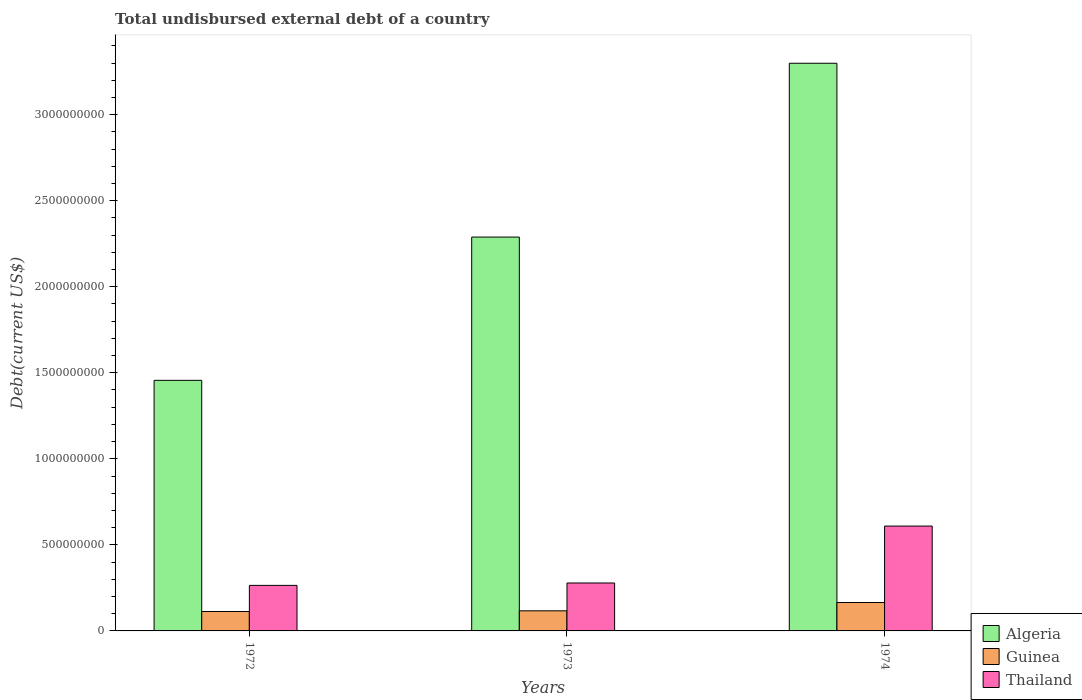How many different coloured bars are there?
Provide a short and direct response. 3. Are the number of bars per tick equal to the number of legend labels?
Your response must be concise. Yes. How many bars are there on the 1st tick from the left?
Offer a very short reply. 3. What is the label of the 3rd group of bars from the left?
Keep it short and to the point. 1974. In how many cases, is the number of bars for a given year not equal to the number of legend labels?
Offer a terse response. 0. What is the total undisbursed external debt in Guinea in 1972?
Your response must be concise. 1.13e+08. Across all years, what is the maximum total undisbursed external debt in Guinea?
Your answer should be very brief. 1.65e+08. Across all years, what is the minimum total undisbursed external debt in Guinea?
Your answer should be compact. 1.13e+08. In which year was the total undisbursed external debt in Thailand maximum?
Offer a terse response. 1974. In which year was the total undisbursed external debt in Algeria minimum?
Your answer should be compact. 1972. What is the total total undisbursed external debt in Thailand in the graph?
Offer a very short reply. 1.15e+09. What is the difference between the total undisbursed external debt in Algeria in 1973 and that in 1974?
Offer a terse response. -1.01e+09. What is the difference between the total undisbursed external debt in Guinea in 1974 and the total undisbursed external debt in Algeria in 1972?
Make the answer very short. -1.29e+09. What is the average total undisbursed external debt in Algeria per year?
Provide a succinct answer. 2.35e+09. In the year 1974, what is the difference between the total undisbursed external debt in Guinea and total undisbursed external debt in Algeria?
Provide a succinct answer. -3.13e+09. In how many years, is the total undisbursed external debt in Guinea greater than 1300000000 US$?
Ensure brevity in your answer.  0. What is the ratio of the total undisbursed external debt in Algeria in 1972 to that in 1974?
Make the answer very short. 0.44. Is the total undisbursed external debt in Thailand in 1973 less than that in 1974?
Give a very brief answer. Yes. Is the difference between the total undisbursed external debt in Guinea in 1972 and 1973 greater than the difference between the total undisbursed external debt in Algeria in 1972 and 1973?
Your answer should be very brief. Yes. What is the difference between the highest and the second highest total undisbursed external debt in Guinea?
Ensure brevity in your answer.  4.82e+07. What is the difference between the highest and the lowest total undisbursed external debt in Algeria?
Offer a very short reply. 1.84e+09. In how many years, is the total undisbursed external debt in Guinea greater than the average total undisbursed external debt in Guinea taken over all years?
Provide a succinct answer. 1. Is the sum of the total undisbursed external debt in Algeria in 1972 and 1974 greater than the maximum total undisbursed external debt in Thailand across all years?
Provide a short and direct response. Yes. What does the 1st bar from the left in 1973 represents?
Offer a terse response. Algeria. What does the 3rd bar from the right in 1972 represents?
Offer a very short reply. Algeria. How many years are there in the graph?
Offer a very short reply. 3. What is the difference between two consecutive major ticks on the Y-axis?
Provide a short and direct response. 5.00e+08. Are the values on the major ticks of Y-axis written in scientific E-notation?
Offer a terse response. No. Does the graph contain any zero values?
Ensure brevity in your answer.  No. Where does the legend appear in the graph?
Ensure brevity in your answer.  Bottom right. How many legend labels are there?
Make the answer very short. 3. What is the title of the graph?
Your answer should be very brief. Total undisbursed external debt of a country. Does "Least developed countries" appear as one of the legend labels in the graph?
Give a very brief answer. No. What is the label or title of the X-axis?
Provide a short and direct response. Years. What is the label or title of the Y-axis?
Your answer should be very brief. Debt(current US$). What is the Debt(current US$) in Algeria in 1972?
Your answer should be very brief. 1.46e+09. What is the Debt(current US$) in Guinea in 1972?
Your response must be concise. 1.13e+08. What is the Debt(current US$) in Thailand in 1972?
Ensure brevity in your answer.  2.65e+08. What is the Debt(current US$) of Algeria in 1973?
Provide a short and direct response. 2.29e+09. What is the Debt(current US$) in Guinea in 1973?
Give a very brief answer. 1.17e+08. What is the Debt(current US$) of Thailand in 1973?
Make the answer very short. 2.79e+08. What is the Debt(current US$) of Algeria in 1974?
Offer a very short reply. 3.30e+09. What is the Debt(current US$) of Guinea in 1974?
Your answer should be compact. 1.65e+08. What is the Debt(current US$) in Thailand in 1974?
Provide a short and direct response. 6.09e+08. Across all years, what is the maximum Debt(current US$) in Algeria?
Provide a succinct answer. 3.30e+09. Across all years, what is the maximum Debt(current US$) of Guinea?
Provide a short and direct response. 1.65e+08. Across all years, what is the maximum Debt(current US$) of Thailand?
Keep it short and to the point. 6.09e+08. Across all years, what is the minimum Debt(current US$) of Algeria?
Give a very brief answer. 1.46e+09. Across all years, what is the minimum Debt(current US$) of Guinea?
Give a very brief answer. 1.13e+08. Across all years, what is the minimum Debt(current US$) in Thailand?
Make the answer very short. 2.65e+08. What is the total Debt(current US$) of Algeria in the graph?
Keep it short and to the point. 7.04e+09. What is the total Debt(current US$) in Guinea in the graph?
Offer a terse response. 3.95e+08. What is the total Debt(current US$) in Thailand in the graph?
Provide a succinct answer. 1.15e+09. What is the difference between the Debt(current US$) of Algeria in 1972 and that in 1973?
Give a very brief answer. -8.32e+08. What is the difference between the Debt(current US$) in Guinea in 1972 and that in 1973?
Offer a very short reply. -3.91e+06. What is the difference between the Debt(current US$) of Thailand in 1972 and that in 1973?
Provide a succinct answer. -1.39e+07. What is the difference between the Debt(current US$) in Algeria in 1972 and that in 1974?
Provide a short and direct response. -1.84e+09. What is the difference between the Debt(current US$) in Guinea in 1972 and that in 1974?
Give a very brief answer. -5.21e+07. What is the difference between the Debt(current US$) of Thailand in 1972 and that in 1974?
Your answer should be compact. -3.45e+08. What is the difference between the Debt(current US$) of Algeria in 1973 and that in 1974?
Ensure brevity in your answer.  -1.01e+09. What is the difference between the Debt(current US$) in Guinea in 1973 and that in 1974?
Give a very brief answer. -4.82e+07. What is the difference between the Debt(current US$) in Thailand in 1973 and that in 1974?
Offer a very short reply. -3.31e+08. What is the difference between the Debt(current US$) in Algeria in 1972 and the Debt(current US$) in Guinea in 1973?
Provide a short and direct response. 1.34e+09. What is the difference between the Debt(current US$) in Algeria in 1972 and the Debt(current US$) in Thailand in 1973?
Offer a very short reply. 1.18e+09. What is the difference between the Debt(current US$) in Guinea in 1972 and the Debt(current US$) in Thailand in 1973?
Give a very brief answer. -1.66e+08. What is the difference between the Debt(current US$) in Algeria in 1972 and the Debt(current US$) in Guinea in 1974?
Keep it short and to the point. 1.29e+09. What is the difference between the Debt(current US$) in Algeria in 1972 and the Debt(current US$) in Thailand in 1974?
Offer a very short reply. 8.47e+08. What is the difference between the Debt(current US$) of Guinea in 1972 and the Debt(current US$) of Thailand in 1974?
Provide a short and direct response. -4.96e+08. What is the difference between the Debt(current US$) in Algeria in 1973 and the Debt(current US$) in Guinea in 1974?
Make the answer very short. 2.12e+09. What is the difference between the Debt(current US$) in Algeria in 1973 and the Debt(current US$) in Thailand in 1974?
Provide a short and direct response. 1.68e+09. What is the difference between the Debt(current US$) of Guinea in 1973 and the Debt(current US$) of Thailand in 1974?
Provide a succinct answer. -4.92e+08. What is the average Debt(current US$) in Algeria per year?
Ensure brevity in your answer.  2.35e+09. What is the average Debt(current US$) of Guinea per year?
Your answer should be compact. 1.32e+08. What is the average Debt(current US$) in Thailand per year?
Your answer should be very brief. 3.84e+08. In the year 1972, what is the difference between the Debt(current US$) of Algeria and Debt(current US$) of Guinea?
Keep it short and to the point. 1.34e+09. In the year 1972, what is the difference between the Debt(current US$) of Algeria and Debt(current US$) of Thailand?
Offer a very short reply. 1.19e+09. In the year 1972, what is the difference between the Debt(current US$) in Guinea and Debt(current US$) in Thailand?
Offer a terse response. -1.52e+08. In the year 1973, what is the difference between the Debt(current US$) in Algeria and Debt(current US$) in Guinea?
Your response must be concise. 2.17e+09. In the year 1973, what is the difference between the Debt(current US$) in Algeria and Debt(current US$) in Thailand?
Offer a terse response. 2.01e+09. In the year 1973, what is the difference between the Debt(current US$) in Guinea and Debt(current US$) in Thailand?
Provide a short and direct response. -1.62e+08. In the year 1974, what is the difference between the Debt(current US$) in Algeria and Debt(current US$) in Guinea?
Your answer should be very brief. 3.13e+09. In the year 1974, what is the difference between the Debt(current US$) in Algeria and Debt(current US$) in Thailand?
Provide a short and direct response. 2.69e+09. In the year 1974, what is the difference between the Debt(current US$) of Guinea and Debt(current US$) of Thailand?
Keep it short and to the point. -4.44e+08. What is the ratio of the Debt(current US$) in Algeria in 1972 to that in 1973?
Provide a succinct answer. 0.64. What is the ratio of the Debt(current US$) in Guinea in 1972 to that in 1973?
Offer a very short reply. 0.97. What is the ratio of the Debt(current US$) of Thailand in 1972 to that in 1973?
Ensure brevity in your answer.  0.95. What is the ratio of the Debt(current US$) of Algeria in 1972 to that in 1974?
Ensure brevity in your answer.  0.44. What is the ratio of the Debt(current US$) of Guinea in 1972 to that in 1974?
Ensure brevity in your answer.  0.68. What is the ratio of the Debt(current US$) in Thailand in 1972 to that in 1974?
Give a very brief answer. 0.43. What is the ratio of the Debt(current US$) of Algeria in 1973 to that in 1974?
Ensure brevity in your answer.  0.69. What is the ratio of the Debt(current US$) of Guinea in 1973 to that in 1974?
Give a very brief answer. 0.71. What is the ratio of the Debt(current US$) of Thailand in 1973 to that in 1974?
Your answer should be compact. 0.46. What is the difference between the highest and the second highest Debt(current US$) of Algeria?
Your answer should be very brief. 1.01e+09. What is the difference between the highest and the second highest Debt(current US$) of Guinea?
Make the answer very short. 4.82e+07. What is the difference between the highest and the second highest Debt(current US$) of Thailand?
Give a very brief answer. 3.31e+08. What is the difference between the highest and the lowest Debt(current US$) in Algeria?
Give a very brief answer. 1.84e+09. What is the difference between the highest and the lowest Debt(current US$) in Guinea?
Your answer should be very brief. 5.21e+07. What is the difference between the highest and the lowest Debt(current US$) of Thailand?
Offer a very short reply. 3.45e+08. 